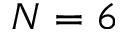Convert formula to latex. <formula><loc_0><loc_0><loc_500><loc_500>N = 6</formula> 